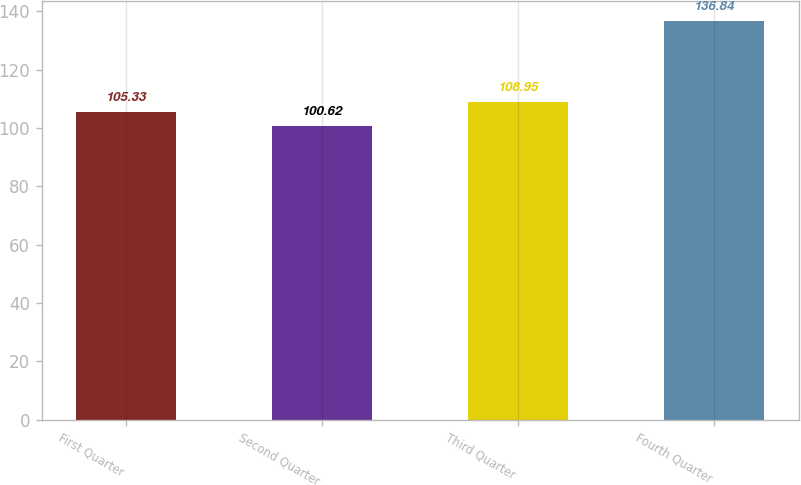<chart> <loc_0><loc_0><loc_500><loc_500><bar_chart><fcel>First Quarter<fcel>Second Quarter<fcel>Third Quarter<fcel>Fourth Quarter<nl><fcel>105.33<fcel>100.62<fcel>108.95<fcel>136.84<nl></chart> 